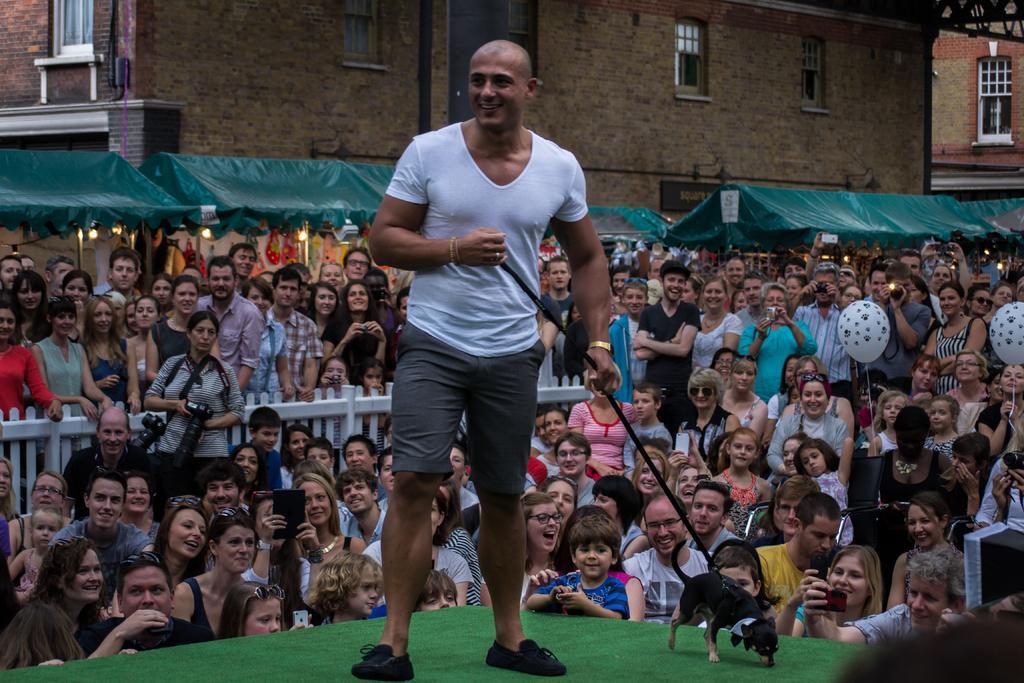Please provide a concise description of this image. In this image I can see a man is standing in the front and I can see he is holding a black colour leash. I can also see he is wearing white colour t shirt, shorts and black shoes. On the right side of this image I can see a black colour dog. In the background number of people where few are holding cameras and few are holding balloons. I can also see few buildings and few tents in the background. On the left side of this image I can see few lights. 